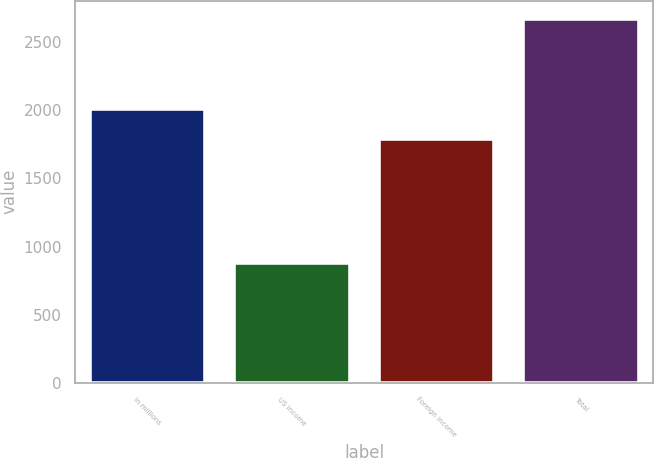Convert chart. <chart><loc_0><loc_0><loc_500><loc_500><bar_chart><fcel>In millions<fcel>US income<fcel>Foreign income<fcel>Total<nl><fcel>2011<fcel>881<fcel>1790<fcel>2671<nl></chart> 